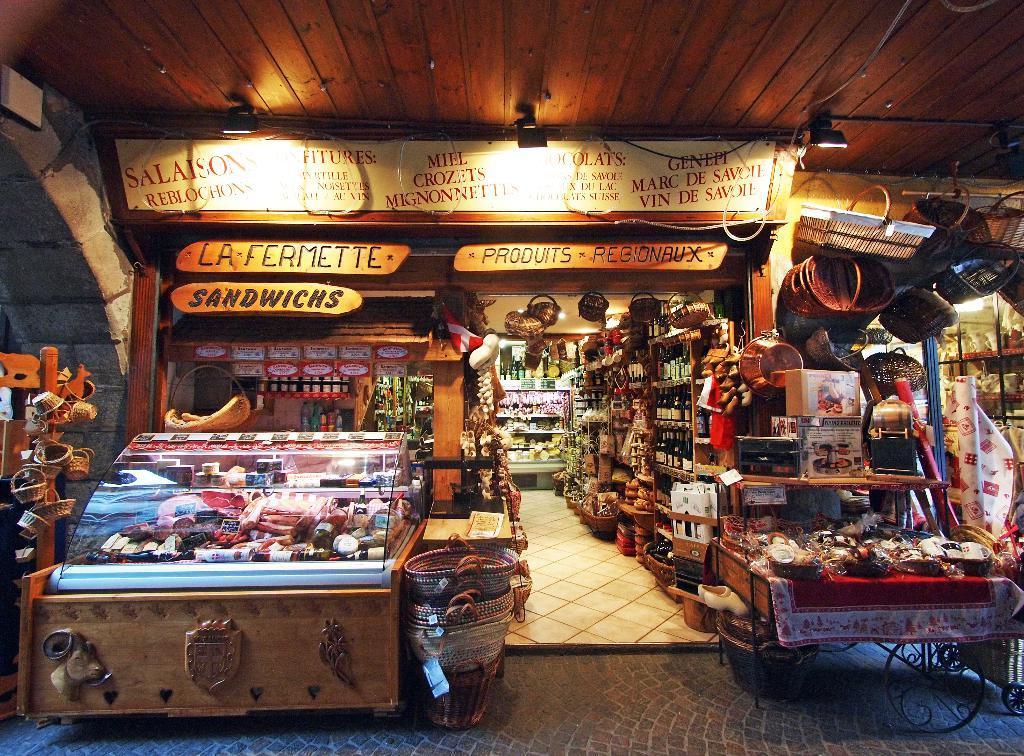<image>
Relay a brief, clear account of the picture shown. A variety of products, such as sandwiches and wines and household items are for sale at a rustic market. 